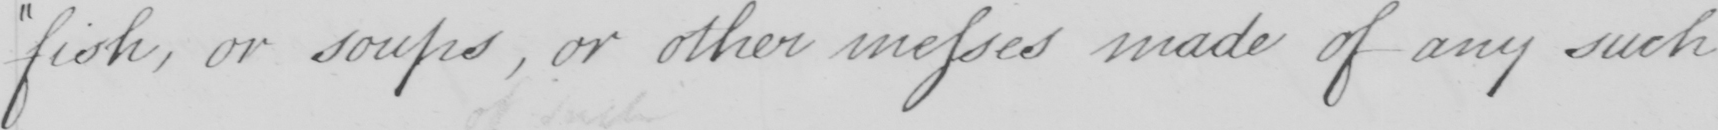What text is written in this handwritten line? fish , or soups , or other messes made of any such 